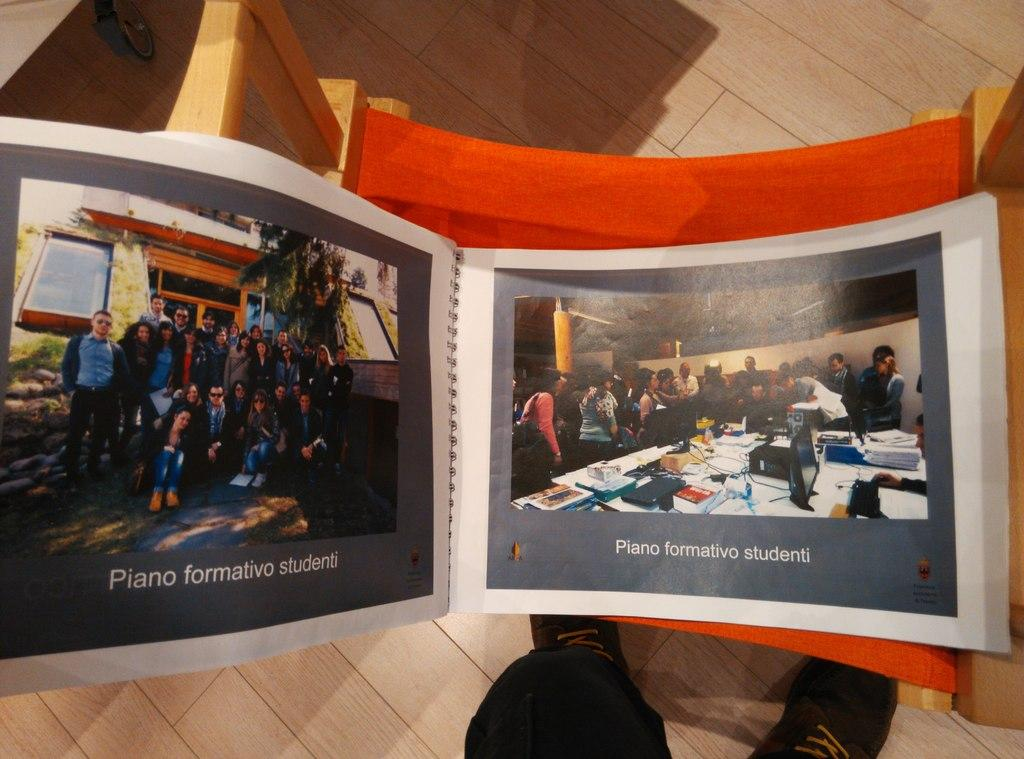<image>
Share a concise interpretation of the image provided. Pictures of groups of people labeled Piano formativo studenti are in a bound book. 